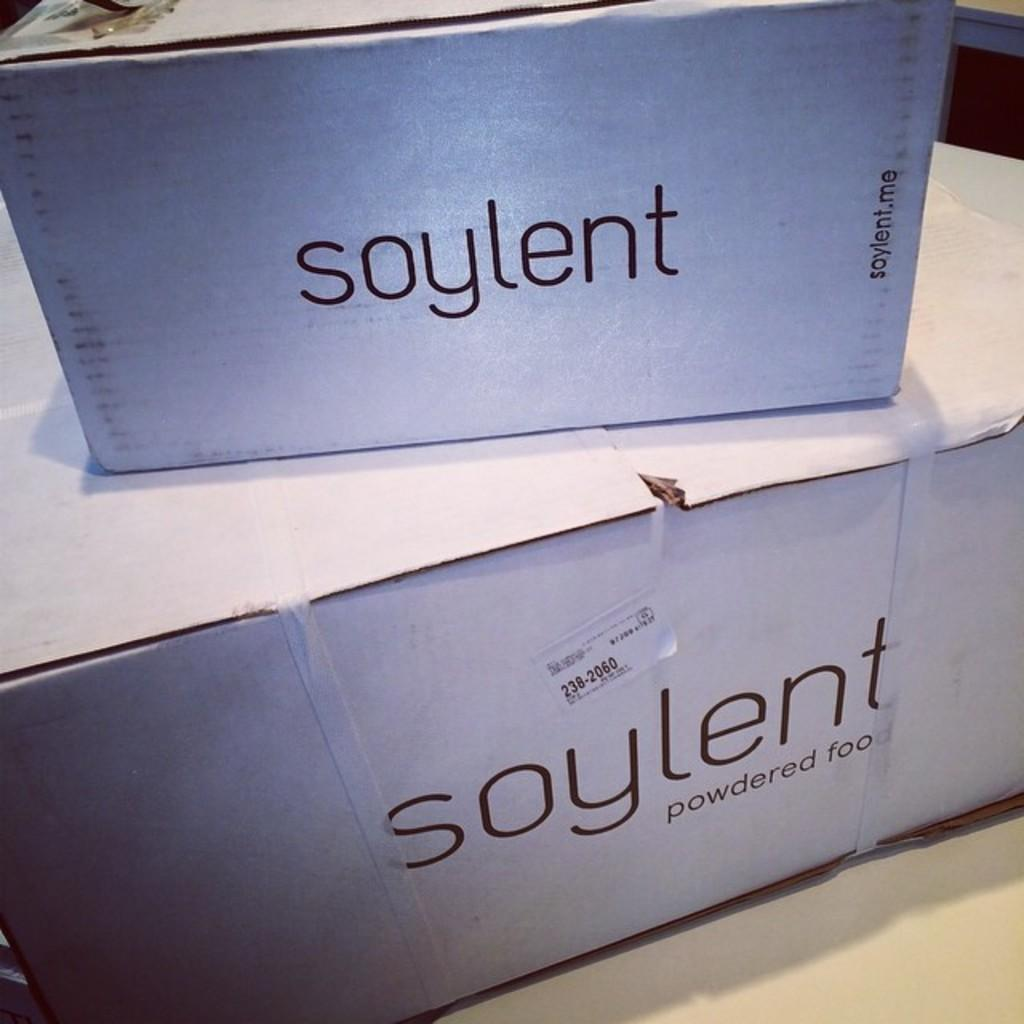<image>
Give a short and clear explanation of the subsequent image. Soylent powdered food is printed on the side of these boxes. 